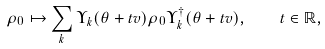<formula> <loc_0><loc_0><loc_500><loc_500>\rho _ { 0 } \mapsto \sum _ { k } \Upsilon _ { k } ( \theta + t v ) \rho _ { 0 } \Upsilon _ { k } ^ { \dagger } ( \theta + t v ) , \quad t \in \mathbb { R } ,</formula> 